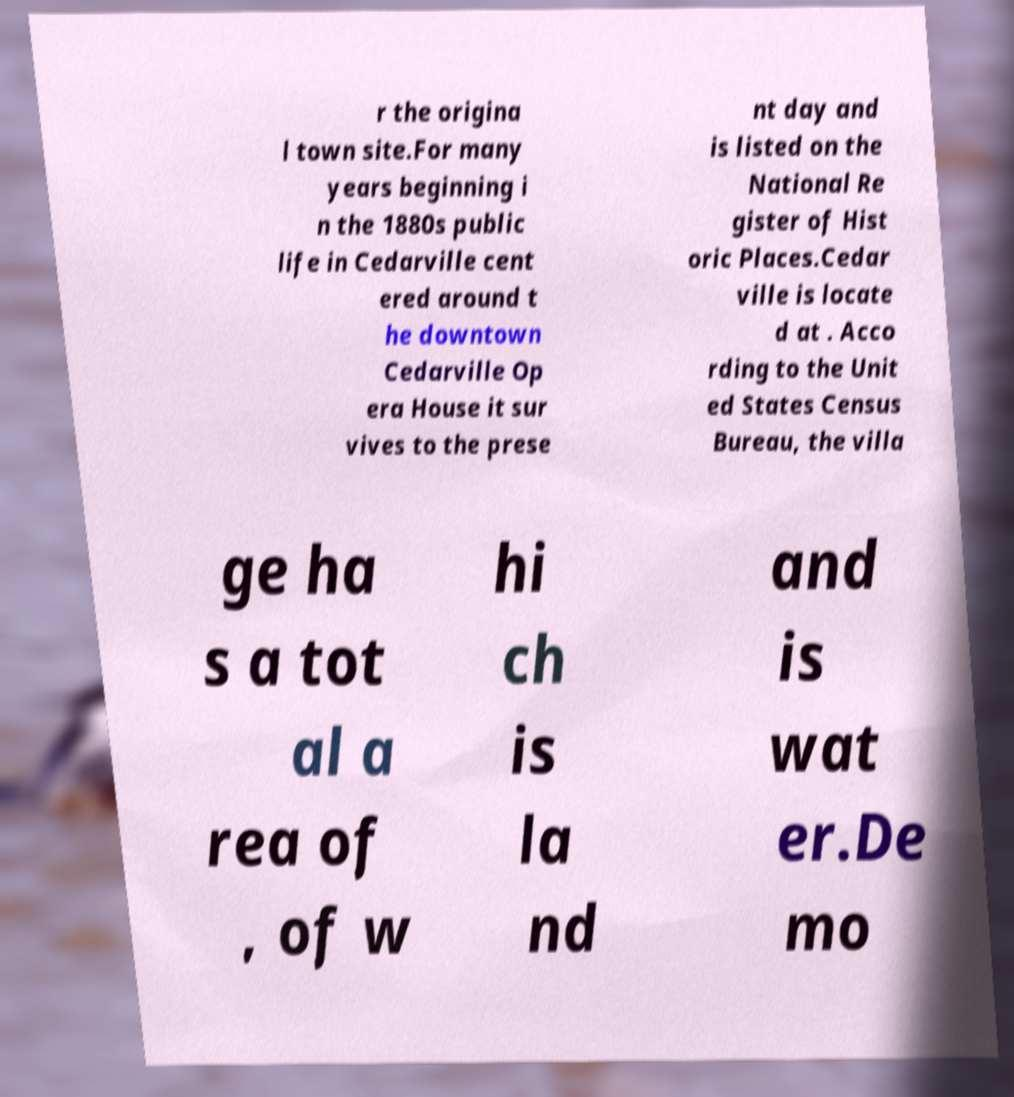Could you assist in decoding the text presented in this image and type it out clearly? r the origina l town site.For many years beginning i n the 1880s public life in Cedarville cent ered around t he downtown Cedarville Op era House it sur vives to the prese nt day and is listed on the National Re gister of Hist oric Places.Cedar ville is locate d at . Acco rding to the Unit ed States Census Bureau, the villa ge ha s a tot al a rea of , of w hi ch is la nd and is wat er.De mo 